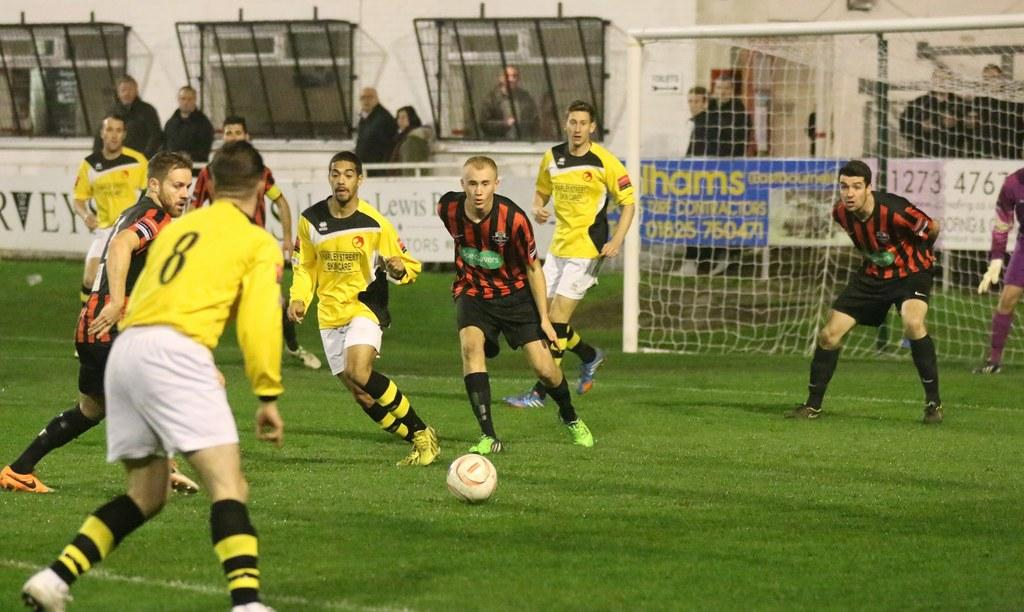<image>
Describe the image concisely. Player number 8 gets ready to get the ball from his opponents 